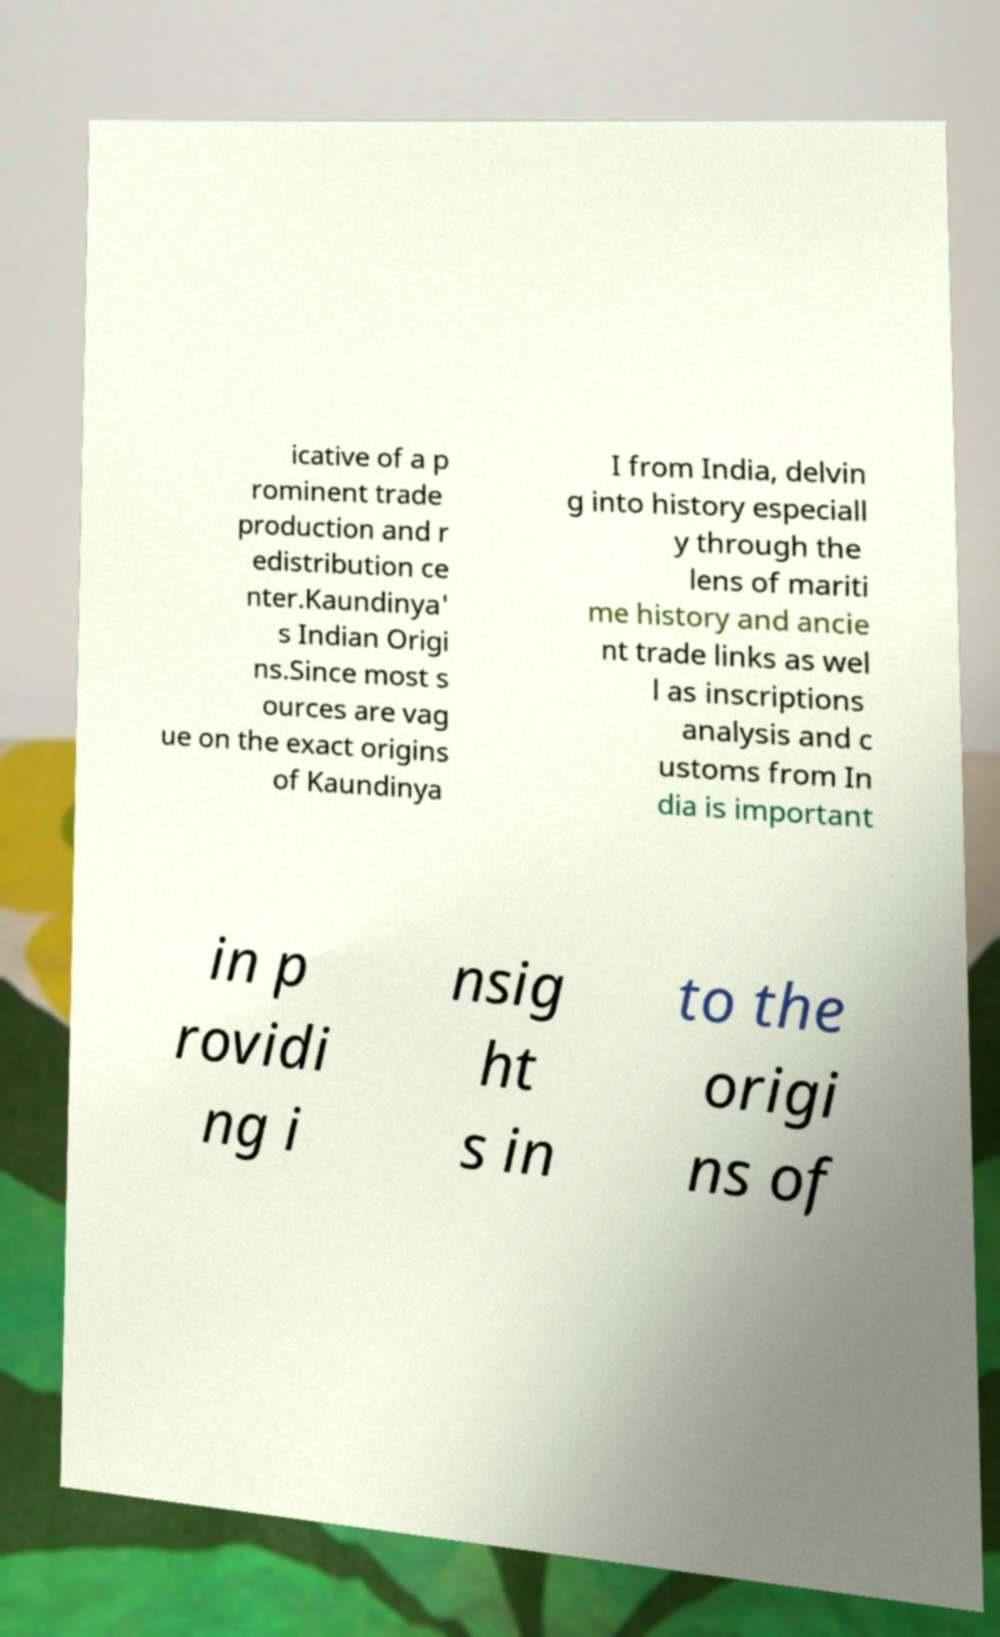Can you read and provide the text displayed in the image?This photo seems to have some interesting text. Can you extract and type it out for me? icative of a p rominent trade production and r edistribution ce nter.Kaundinya' s Indian Origi ns.Since most s ources are vag ue on the exact origins of Kaundinya I from India, delvin g into history especiall y through the lens of mariti me history and ancie nt trade links as wel l as inscriptions analysis and c ustoms from In dia is important in p rovidi ng i nsig ht s in to the origi ns of 